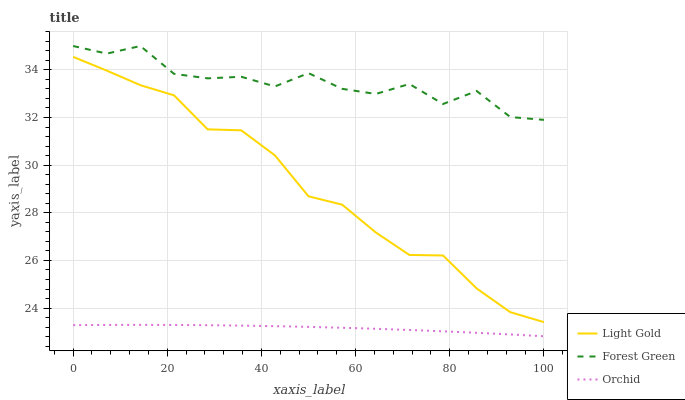Does Orchid have the minimum area under the curve?
Answer yes or no. Yes. Does Forest Green have the maximum area under the curve?
Answer yes or no. Yes. Does Light Gold have the minimum area under the curve?
Answer yes or no. No. Does Light Gold have the maximum area under the curve?
Answer yes or no. No. Is Orchid the smoothest?
Answer yes or no. Yes. Is Forest Green the roughest?
Answer yes or no. Yes. Is Light Gold the smoothest?
Answer yes or no. No. Is Light Gold the roughest?
Answer yes or no. No. Does Light Gold have the lowest value?
Answer yes or no. No. Does Light Gold have the highest value?
Answer yes or no. No. Is Light Gold less than Forest Green?
Answer yes or no. Yes. Is Light Gold greater than Orchid?
Answer yes or no. Yes. Does Light Gold intersect Forest Green?
Answer yes or no. No. 